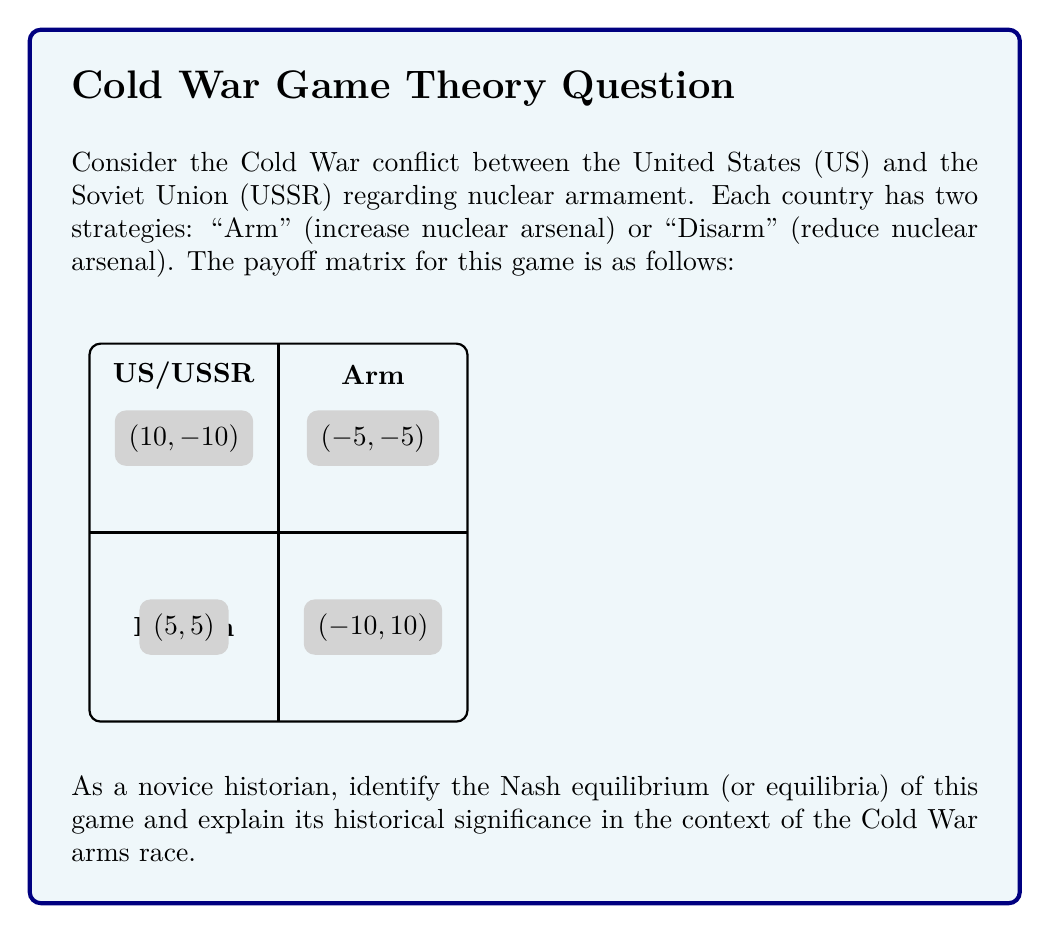Could you help me with this problem? To solve this problem, we need to follow these steps:

1) Understand the concept of Nash equilibrium:
   A Nash equilibrium is a set of strategies where no player can unilaterally change their strategy to increase their payoff.

2) Analyze each player's best responses:
   For the US:
   - If USSR arms, US best response is to arm (-5 > -10)
   - If USSR disarms, US best response is to arm (10 > 5)
   
   For the USSR:
   - If US arms, USSR best response is to arm (-5 > -10)
   - If US disarms, USSR best response is to arm (10 > 5)

3) Identify the Nash equilibrium:
   The only strategy profile where both players are playing their best responses simultaneously is (Arm, Arm). This is the Nash equilibrium.

4) Historical context:
   This equilibrium reflects the actual outcome of the Cold War arms race. Both superpowers continued to build up their nuclear arsenals despite the negative consequences (represented by the -5, -5 payoff) because unilateral disarmament would leave them vulnerable (payoffs of -10).

5) Significance:
   This game theoretic model helps explain why the arms race persisted for decades. The equilibrium demonstrates the strategic dilemma known as the "security dilemma" or "prisoner's dilemma" in international relations, where rational self-interest leads to a suboptimal outcome for both parties.

The Nash equilibrium of (Arm, Arm) illustrates how game theory can model complex historical conflicts and provide insights into the strategic reasoning behind seemingly irrational behavior.
Answer: Nash equilibrium: (Arm, Arm) 